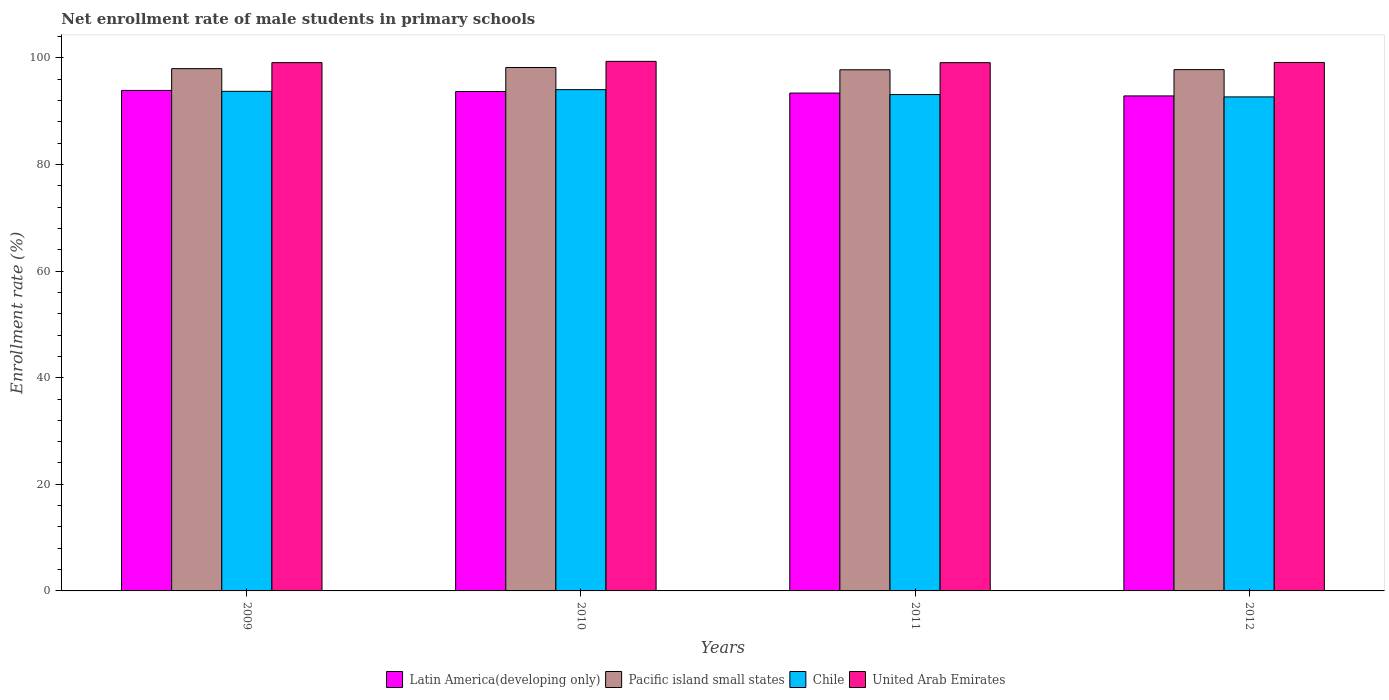How many groups of bars are there?
Provide a short and direct response. 4. Are the number of bars per tick equal to the number of legend labels?
Keep it short and to the point. Yes. How many bars are there on the 2nd tick from the left?
Make the answer very short. 4. What is the label of the 4th group of bars from the left?
Keep it short and to the point. 2012. In how many cases, is the number of bars for a given year not equal to the number of legend labels?
Ensure brevity in your answer.  0. What is the net enrollment rate of male students in primary schools in Pacific island small states in 2010?
Provide a short and direct response. 98.2. Across all years, what is the maximum net enrollment rate of male students in primary schools in Pacific island small states?
Your answer should be very brief. 98.2. Across all years, what is the minimum net enrollment rate of male students in primary schools in Chile?
Offer a very short reply. 92.69. In which year was the net enrollment rate of male students in primary schools in Latin America(developing only) maximum?
Make the answer very short. 2009. What is the total net enrollment rate of male students in primary schools in Chile in the graph?
Provide a succinct answer. 373.59. What is the difference between the net enrollment rate of male students in primary schools in Pacific island small states in 2011 and that in 2012?
Your answer should be very brief. -0.02. What is the difference between the net enrollment rate of male students in primary schools in United Arab Emirates in 2011 and the net enrollment rate of male students in primary schools in Pacific island small states in 2012?
Offer a terse response. 1.31. What is the average net enrollment rate of male students in primary schools in Pacific island small states per year?
Offer a terse response. 97.94. In the year 2009, what is the difference between the net enrollment rate of male students in primary schools in United Arab Emirates and net enrollment rate of male students in primary schools in Latin America(developing only)?
Keep it short and to the point. 5.22. What is the ratio of the net enrollment rate of male students in primary schools in Latin America(developing only) in 2010 to that in 2012?
Make the answer very short. 1.01. Is the difference between the net enrollment rate of male students in primary schools in United Arab Emirates in 2010 and 2011 greater than the difference between the net enrollment rate of male students in primary schools in Latin America(developing only) in 2010 and 2011?
Give a very brief answer. No. What is the difference between the highest and the second highest net enrollment rate of male students in primary schools in United Arab Emirates?
Provide a short and direct response. 0.21. What is the difference between the highest and the lowest net enrollment rate of male students in primary schools in Latin America(developing only)?
Provide a short and direct response. 1.03. In how many years, is the net enrollment rate of male students in primary schools in Pacific island small states greater than the average net enrollment rate of male students in primary schools in Pacific island small states taken over all years?
Your response must be concise. 2. Is it the case that in every year, the sum of the net enrollment rate of male students in primary schools in Chile and net enrollment rate of male students in primary schools in Pacific island small states is greater than the sum of net enrollment rate of male students in primary schools in United Arab Emirates and net enrollment rate of male students in primary schools in Latin America(developing only)?
Your response must be concise. Yes. What does the 3rd bar from the left in 2009 represents?
Ensure brevity in your answer.  Chile. What does the 2nd bar from the right in 2010 represents?
Keep it short and to the point. Chile. How many years are there in the graph?
Give a very brief answer. 4. Are the values on the major ticks of Y-axis written in scientific E-notation?
Provide a short and direct response. No. How are the legend labels stacked?
Give a very brief answer. Horizontal. What is the title of the graph?
Your response must be concise. Net enrollment rate of male students in primary schools. What is the label or title of the Y-axis?
Offer a terse response. Enrollment rate (%). What is the Enrollment rate (%) of Latin America(developing only) in 2009?
Your answer should be compact. 93.9. What is the Enrollment rate (%) of Pacific island small states in 2009?
Offer a terse response. 97.99. What is the Enrollment rate (%) of Chile in 2009?
Offer a terse response. 93.73. What is the Enrollment rate (%) in United Arab Emirates in 2009?
Provide a succinct answer. 99.11. What is the Enrollment rate (%) of Latin America(developing only) in 2010?
Offer a terse response. 93.7. What is the Enrollment rate (%) of Pacific island small states in 2010?
Your answer should be very brief. 98.2. What is the Enrollment rate (%) of Chile in 2010?
Keep it short and to the point. 94.05. What is the Enrollment rate (%) of United Arab Emirates in 2010?
Give a very brief answer. 99.35. What is the Enrollment rate (%) of Latin America(developing only) in 2011?
Ensure brevity in your answer.  93.4. What is the Enrollment rate (%) of Pacific island small states in 2011?
Provide a succinct answer. 97.78. What is the Enrollment rate (%) of Chile in 2011?
Offer a terse response. 93.12. What is the Enrollment rate (%) in United Arab Emirates in 2011?
Your answer should be very brief. 99.11. What is the Enrollment rate (%) in Latin America(developing only) in 2012?
Provide a short and direct response. 92.87. What is the Enrollment rate (%) of Pacific island small states in 2012?
Offer a very short reply. 97.8. What is the Enrollment rate (%) in Chile in 2012?
Your response must be concise. 92.69. What is the Enrollment rate (%) of United Arab Emirates in 2012?
Your answer should be very brief. 99.15. Across all years, what is the maximum Enrollment rate (%) of Latin America(developing only)?
Your answer should be very brief. 93.9. Across all years, what is the maximum Enrollment rate (%) in Pacific island small states?
Ensure brevity in your answer.  98.2. Across all years, what is the maximum Enrollment rate (%) of Chile?
Offer a terse response. 94.05. Across all years, what is the maximum Enrollment rate (%) of United Arab Emirates?
Your answer should be compact. 99.35. Across all years, what is the minimum Enrollment rate (%) of Latin America(developing only)?
Offer a very short reply. 92.87. Across all years, what is the minimum Enrollment rate (%) in Pacific island small states?
Provide a short and direct response. 97.78. Across all years, what is the minimum Enrollment rate (%) of Chile?
Your response must be concise. 92.69. Across all years, what is the minimum Enrollment rate (%) of United Arab Emirates?
Offer a terse response. 99.11. What is the total Enrollment rate (%) of Latin America(developing only) in the graph?
Your response must be concise. 373.88. What is the total Enrollment rate (%) in Pacific island small states in the graph?
Make the answer very short. 391.77. What is the total Enrollment rate (%) of Chile in the graph?
Your response must be concise. 373.59. What is the total Enrollment rate (%) of United Arab Emirates in the graph?
Ensure brevity in your answer.  396.73. What is the difference between the Enrollment rate (%) of Latin America(developing only) in 2009 and that in 2010?
Provide a short and direct response. 0.2. What is the difference between the Enrollment rate (%) of Pacific island small states in 2009 and that in 2010?
Your answer should be compact. -0.22. What is the difference between the Enrollment rate (%) of Chile in 2009 and that in 2010?
Provide a short and direct response. -0.32. What is the difference between the Enrollment rate (%) of United Arab Emirates in 2009 and that in 2010?
Ensure brevity in your answer.  -0.24. What is the difference between the Enrollment rate (%) in Latin America(developing only) in 2009 and that in 2011?
Your response must be concise. 0.49. What is the difference between the Enrollment rate (%) in Pacific island small states in 2009 and that in 2011?
Offer a very short reply. 0.21. What is the difference between the Enrollment rate (%) in Chile in 2009 and that in 2011?
Offer a very short reply. 0.61. What is the difference between the Enrollment rate (%) in United Arab Emirates in 2009 and that in 2011?
Provide a succinct answer. 0. What is the difference between the Enrollment rate (%) of Latin America(developing only) in 2009 and that in 2012?
Your response must be concise. 1.03. What is the difference between the Enrollment rate (%) in Pacific island small states in 2009 and that in 2012?
Ensure brevity in your answer.  0.19. What is the difference between the Enrollment rate (%) of Chile in 2009 and that in 2012?
Your answer should be very brief. 1.04. What is the difference between the Enrollment rate (%) in United Arab Emirates in 2009 and that in 2012?
Give a very brief answer. -0.03. What is the difference between the Enrollment rate (%) of Latin America(developing only) in 2010 and that in 2011?
Give a very brief answer. 0.3. What is the difference between the Enrollment rate (%) in Pacific island small states in 2010 and that in 2011?
Give a very brief answer. 0.43. What is the difference between the Enrollment rate (%) of Chile in 2010 and that in 2011?
Provide a short and direct response. 0.92. What is the difference between the Enrollment rate (%) in United Arab Emirates in 2010 and that in 2011?
Make the answer very short. 0.24. What is the difference between the Enrollment rate (%) in Latin America(developing only) in 2010 and that in 2012?
Give a very brief answer. 0.83. What is the difference between the Enrollment rate (%) in Pacific island small states in 2010 and that in 2012?
Ensure brevity in your answer.  0.4. What is the difference between the Enrollment rate (%) in Chile in 2010 and that in 2012?
Make the answer very short. 1.36. What is the difference between the Enrollment rate (%) in United Arab Emirates in 2010 and that in 2012?
Your answer should be very brief. 0.21. What is the difference between the Enrollment rate (%) in Latin America(developing only) in 2011 and that in 2012?
Offer a very short reply. 0.53. What is the difference between the Enrollment rate (%) of Pacific island small states in 2011 and that in 2012?
Ensure brevity in your answer.  -0.03. What is the difference between the Enrollment rate (%) of Chile in 2011 and that in 2012?
Provide a succinct answer. 0.44. What is the difference between the Enrollment rate (%) of United Arab Emirates in 2011 and that in 2012?
Ensure brevity in your answer.  -0.04. What is the difference between the Enrollment rate (%) of Latin America(developing only) in 2009 and the Enrollment rate (%) of Pacific island small states in 2010?
Make the answer very short. -4.3. What is the difference between the Enrollment rate (%) of Latin America(developing only) in 2009 and the Enrollment rate (%) of Chile in 2010?
Your answer should be very brief. -0.15. What is the difference between the Enrollment rate (%) in Latin America(developing only) in 2009 and the Enrollment rate (%) in United Arab Emirates in 2010?
Your answer should be compact. -5.46. What is the difference between the Enrollment rate (%) of Pacific island small states in 2009 and the Enrollment rate (%) of Chile in 2010?
Provide a short and direct response. 3.94. What is the difference between the Enrollment rate (%) of Pacific island small states in 2009 and the Enrollment rate (%) of United Arab Emirates in 2010?
Your response must be concise. -1.37. What is the difference between the Enrollment rate (%) of Chile in 2009 and the Enrollment rate (%) of United Arab Emirates in 2010?
Your answer should be very brief. -5.62. What is the difference between the Enrollment rate (%) in Latin America(developing only) in 2009 and the Enrollment rate (%) in Pacific island small states in 2011?
Your answer should be very brief. -3.88. What is the difference between the Enrollment rate (%) in Latin America(developing only) in 2009 and the Enrollment rate (%) in Chile in 2011?
Your answer should be compact. 0.78. What is the difference between the Enrollment rate (%) of Latin America(developing only) in 2009 and the Enrollment rate (%) of United Arab Emirates in 2011?
Give a very brief answer. -5.21. What is the difference between the Enrollment rate (%) of Pacific island small states in 2009 and the Enrollment rate (%) of Chile in 2011?
Ensure brevity in your answer.  4.86. What is the difference between the Enrollment rate (%) of Pacific island small states in 2009 and the Enrollment rate (%) of United Arab Emirates in 2011?
Keep it short and to the point. -1.12. What is the difference between the Enrollment rate (%) in Chile in 2009 and the Enrollment rate (%) in United Arab Emirates in 2011?
Keep it short and to the point. -5.38. What is the difference between the Enrollment rate (%) in Latin America(developing only) in 2009 and the Enrollment rate (%) in Pacific island small states in 2012?
Offer a terse response. -3.9. What is the difference between the Enrollment rate (%) in Latin America(developing only) in 2009 and the Enrollment rate (%) in Chile in 2012?
Provide a succinct answer. 1.21. What is the difference between the Enrollment rate (%) in Latin America(developing only) in 2009 and the Enrollment rate (%) in United Arab Emirates in 2012?
Provide a succinct answer. -5.25. What is the difference between the Enrollment rate (%) of Pacific island small states in 2009 and the Enrollment rate (%) of Chile in 2012?
Keep it short and to the point. 5.3. What is the difference between the Enrollment rate (%) of Pacific island small states in 2009 and the Enrollment rate (%) of United Arab Emirates in 2012?
Ensure brevity in your answer.  -1.16. What is the difference between the Enrollment rate (%) of Chile in 2009 and the Enrollment rate (%) of United Arab Emirates in 2012?
Ensure brevity in your answer.  -5.42. What is the difference between the Enrollment rate (%) in Latin America(developing only) in 2010 and the Enrollment rate (%) in Pacific island small states in 2011?
Ensure brevity in your answer.  -4.07. What is the difference between the Enrollment rate (%) of Latin America(developing only) in 2010 and the Enrollment rate (%) of Chile in 2011?
Your response must be concise. 0.58. What is the difference between the Enrollment rate (%) in Latin America(developing only) in 2010 and the Enrollment rate (%) in United Arab Emirates in 2011?
Ensure brevity in your answer.  -5.41. What is the difference between the Enrollment rate (%) of Pacific island small states in 2010 and the Enrollment rate (%) of Chile in 2011?
Provide a succinct answer. 5.08. What is the difference between the Enrollment rate (%) of Pacific island small states in 2010 and the Enrollment rate (%) of United Arab Emirates in 2011?
Offer a terse response. -0.91. What is the difference between the Enrollment rate (%) in Chile in 2010 and the Enrollment rate (%) in United Arab Emirates in 2011?
Provide a succinct answer. -5.06. What is the difference between the Enrollment rate (%) of Latin America(developing only) in 2010 and the Enrollment rate (%) of Pacific island small states in 2012?
Provide a short and direct response. -4.1. What is the difference between the Enrollment rate (%) in Latin America(developing only) in 2010 and the Enrollment rate (%) in Chile in 2012?
Ensure brevity in your answer.  1.01. What is the difference between the Enrollment rate (%) of Latin America(developing only) in 2010 and the Enrollment rate (%) of United Arab Emirates in 2012?
Your answer should be very brief. -5.45. What is the difference between the Enrollment rate (%) in Pacific island small states in 2010 and the Enrollment rate (%) in Chile in 2012?
Your answer should be very brief. 5.52. What is the difference between the Enrollment rate (%) of Pacific island small states in 2010 and the Enrollment rate (%) of United Arab Emirates in 2012?
Offer a very short reply. -0.94. What is the difference between the Enrollment rate (%) of Chile in 2010 and the Enrollment rate (%) of United Arab Emirates in 2012?
Ensure brevity in your answer.  -5.1. What is the difference between the Enrollment rate (%) of Latin America(developing only) in 2011 and the Enrollment rate (%) of Pacific island small states in 2012?
Make the answer very short. -4.4. What is the difference between the Enrollment rate (%) in Latin America(developing only) in 2011 and the Enrollment rate (%) in Chile in 2012?
Give a very brief answer. 0.72. What is the difference between the Enrollment rate (%) in Latin America(developing only) in 2011 and the Enrollment rate (%) in United Arab Emirates in 2012?
Make the answer very short. -5.74. What is the difference between the Enrollment rate (%) in Pacific island small states in 2011 and the Enrollment rate (%) in Chile in 2012?
Offer a terse response. 5.09. What is the difference between the Enrollment rate (%) of Pacific island small states in 2011 and the Enrollment rate (%) of United Arab Emirates in 2012?
Offer a very short reply. -1.37. What is the difference between the Enrollment rate (%) in Chile in 2011 and the Enrollment rate (%) in United Arab Emirates in 2012?
Offer a terse response. -6.03. What is the average Enrollment rate (%) of Latin America(developing only) per year?
Your response must be concise. 93.47. What is the average Enrollment rate (%) of Pacific island small states per year?
Your answer should be very brief. 97.94. What is the average Enrollment rate (%) of Chile per year?
Offer a terse response. 93.4. What is the average Enrollment rate (%) in United Arab Emirates per year?
Offer a very short reply. 99.18. In the year 2009, what is the difference between the Enrollment rate (%) in Latin America(developing only) and Enrollment rate (%) in Pacific island small states?
Your response must be concise. -4.09. In the year 2009, what is the difference between the Enrollment rate (%) in Latin America(developing only) and Enrollment rate (%) in Chile?
Your answer should be compact. 0.17. In the year 2009, what is the difference between the Enrollment rate (%) in Latin America(developing only) and Enrollment rate (%) in United Arab Emirates?
Keep it short and to the point. -5.22. In the year 2009, what is the difference between the Enrollment rate (%) in Pacific island small states and Enrollment rate (%) in Chile?
Provide a short and direct response. 4.26. In the year 2009, what is the difference between the Enrollment rate (%) in Pacific island small states and Enrollment rate (%) in United Arab Emirates?
Ensure brevity in your answer.  -1.13. In the year 2009, what is the difference between the Enrollment rate (%) of Chile and Enrollment rate (%) of United Arab Emirates?
Offer a very short reply. -5.38. In the year 2010, what is the difference between the Enrollment rate (%) of Latin America(developing only) and Enrollment rate (%) of Pacific island small states?
Ensure brevity in your answer.  -4.5. In the year 2010, what is the difference between the Enrollment rate (%) of Latin America(developing only) and Enrollment rate (%) of Chile?
Offer a very short reply. -0.35. In the year 2010, what is the difference between the Enrollment rate (%) in Latin America(developing only) and Enrollment rate (%) in United Arab Emirates?
Give a very brief answer. -5.65. In the year 2010, what is the difference between the Enrollment rate (%) in Pacific island small states and Enrollment rate (%) in Chile?
Make the answer very short. 4.16. In the year 2010, what is the difference between the Enrollment rate (%) in Pacific island small states and Enrollment rate (%) in United Arab Emirates?
Make the answer very short. -1.15. In the year 2010, what is the difference between the Enrollment rate (%) in Chile and Enrollment rate (%) in United Arab Emirates?
Provide a succinct answer. -5.31. In the year 2011, what is the difference between the Enrollment rate (%) in Latin America(developing only) and Enrollment rate (%) in Pacific island small states?
Keep it short and to the point. -4.37. In the year 2011, what is the difference between the Enrollment rate (%) of Latin America(developing only) and Enrollment rate (%) of Chile?
Keep it short and to the point. 0.28. In the year 2011, what is the difference between the Enrollment rate (%) in Latin America(developing only) and Enrollment rate (%) in United Arab Emirates?
Keep it short and to the point. -5.71. In the year 2011, what is the difference between the Enrollment rate (%) of Pacific island small states and Enrollment rate (%) of Chile?
Offer a terse response. 4.65. In the year 2011, what is the difference between the Enrollment rate (%) of Pacific island small states and Enrollment rate (%) of United Arab Emirates?
Your response must be concise. -1.33. In the year 2011, what is the difference between the Enrollment rate (%) in Chile and Enrollment rate (%) in United Arab Emirates?
Keep it short and to the point. -5.99. In the year 2012, what is the difference between the Enrollment rate (%) of Latin America(developing only) and Enrollment rate (%) of Pacific island small states?
Ensure brevity in your answer.  -4.93. In the year 2012, what is the difference between the Enrollment rate (%) in Latin America(developing only) and Enrollment rate (%) in Chile?
Provide a succinct answer. 0.18. In the year 2012, what is the difference between the Enrollment rate (%) in Latin America(developing only) and Enrollment rate (%) in United Arab Emirates?
Your answer should be compact. -6.28. In the year 2012, what is the difference between the Enrollment rate (%) in Pacific island small states and Enrollment rate (%) in Chile?
Give a very brief answer. 5.11. In the year 2012, what is the difference between the Enrollment rate (%) of Pacific island small states and Enrollment rate (%) of United Arab Emirates?
Provide a succinct answer. -1.35. In the year 2012, what is the difference between the Enrollment rate (%) in Chile and Enrollment rate (%) in United Arab Emirates?
Ensure brevity in your answer.  -6.46. What is the ratio of the Enrollment rate (%) of Pacific island small states in 2009 to that in 2010?
Ensure brevity in your answer.  1. What is the ratio of the Enrollment rate (%) in Chile in 2009 to that in 2010?
Keep it short and to the point. 1. What is the ratio of the Enrollment rate (%) of United Arab Emirates in 2009 to that in 2010?
Your response must be concise. 1. What is the ratio of the Enrollment rate (%) in Latin America(developing only) in 2009 to that in 2011?
Offer a very short reply. 1.01. What is the ratio of the Enrollment rate (%) of Pacific island small states in 2009 to that in 2011?
Provide a succinct answer. 1. What is the ratio of the Enrollment rate (%) of Chile in 2009 to that in 2011?
Keep it short and to the point. 1.01. What is the ratio of the Enrollment rate (%) of United Arab Emirates in 2009 to that in 2011?
Give a very brief answer. 1. What is the ratio of the Enrollment rate (%) in Latin America(developing only) in 2009 to that in 2012?
Your response must be concise. 1.01. What is the ratio of the Enrollment rate (%) of Pacific island small states in 2009 to that in 2012?
Provide a succinct answer. 1. What is the ratio of the Enrollment rate (%) in Chile in 2009 to that in 2012?
Give a very brief answer. 1.01. What is the ratio of the Enrollment rate (%) of Latin America(developing only) in 2010 to that in 2011?
Your response must be concise. 1. What is the ratio of the Enrollment rate (%) in Chile in 2010 to that in 2011?
Your answer should be compact. 1.01. What is the ratio of the Enrollment rate (%) of United Arab Emirates in 2010 to that in 2011?
Provide a succinct answer. 1. What is the ratio of the Enrollment rate (%) of Latin America(developing only) in 2010 to that in 2012?
Provide a succinct answer. 1.01. What is the ratio of the Enrollment rate (%) of Pacific island small states in 2010 to that in 2012?
Your answer should be compact. 1. What is the ratio of the Enrollment rate (%) of Chile in 2010 to that in 2012?
Your answer should be compact. 1.01. What is the ratio of the Enrollment rate (%) in United Arab Emirates in 2010 to that in 2012?
Offer a terse response. 1. What is the ratio of the Enrollment rate (%) in Pacific island small states in 2011 to that in 2012?
Your answer should be compact. 1. What is the ratio of the Enrollment rate (%) in United Arab Emirates in 2011 to that in 2012?
Your answer should be compact. 1. What is the difference between the highest and the second highest Enrollment rate (%) in Latin America(developing only)?
Provide a succinct answer. 0.2. What is the difference between the highest and the second highest Enrollment rate (%) in Pacific island small states?
Offer a terse response. 0.22. What is the difference between the highest and the second highest Enrollment rate (%) of Chile?
Your answer should be very brief. 0.32. What is the difference between the highest and the second highest Enrollment rate (%) in United Arab Emirates?
Provide a succinct answer. 0.21. What is the difference between the highest and the lowest Enrollment rate (%) of Latin America(developing only)?
Make the answer very short. 1.03. What is the difference between the highest and the lowest Enrollment rate (%) in Pacific island small states?
Make the answer very short. 0.43. What is the difference between the highest and the lowest Enrollment rate (%) of Chile?
Provide a short and direct response. 1.36. What is the difference between the highest and the lowest Enrollment rate (%) in United Arab Emirates?
Ensure brevity in your answer.  0.24. 